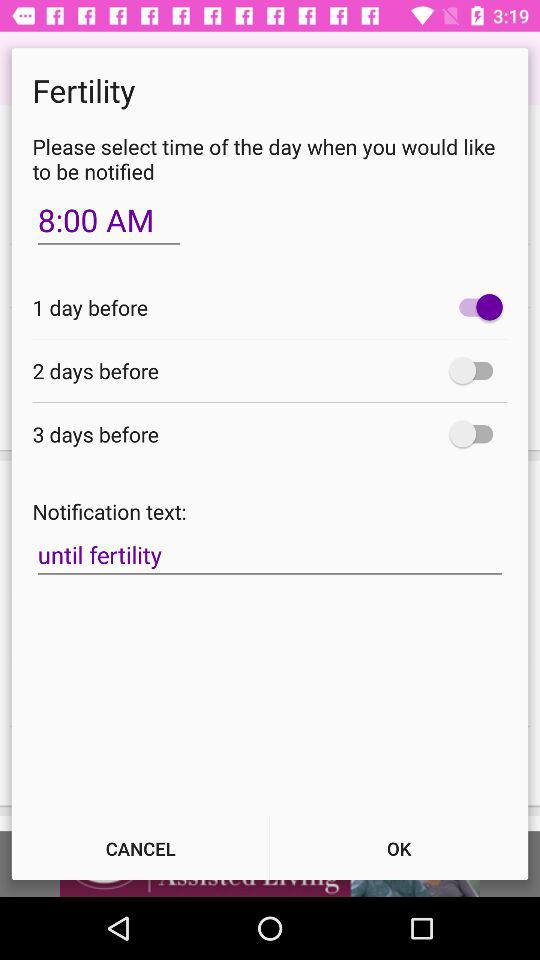What is the status of "3 days before"? The status is "off". 